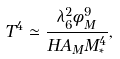<formula> <loc_0><loc_0><loc_500><loc_500>T ^ { 4 } \simeq \frac { \lambda _ { 6 } ^ { 2 } \phi _ { M } ^ { 9 } } { H A _ { M } M _ { * } ^ { 4 } } ,</formula> 